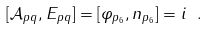Convert formula to latex. <formula><loc_0><loc_0><loc_500><loc_500>[ \mathcal { A } _ { p q } , E _ { p q } ] = [ \varphi _ { p _ { 6 } } , n _ { p _ { 6 } } ] = i \ .</formula> 